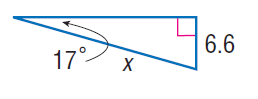Answer the mathemtical geometry problem and directly provide the correct option letter.
Question: Find x.
Choices: A: 11.4 B: 22.6 C: 32.3 D: 43.2 B 